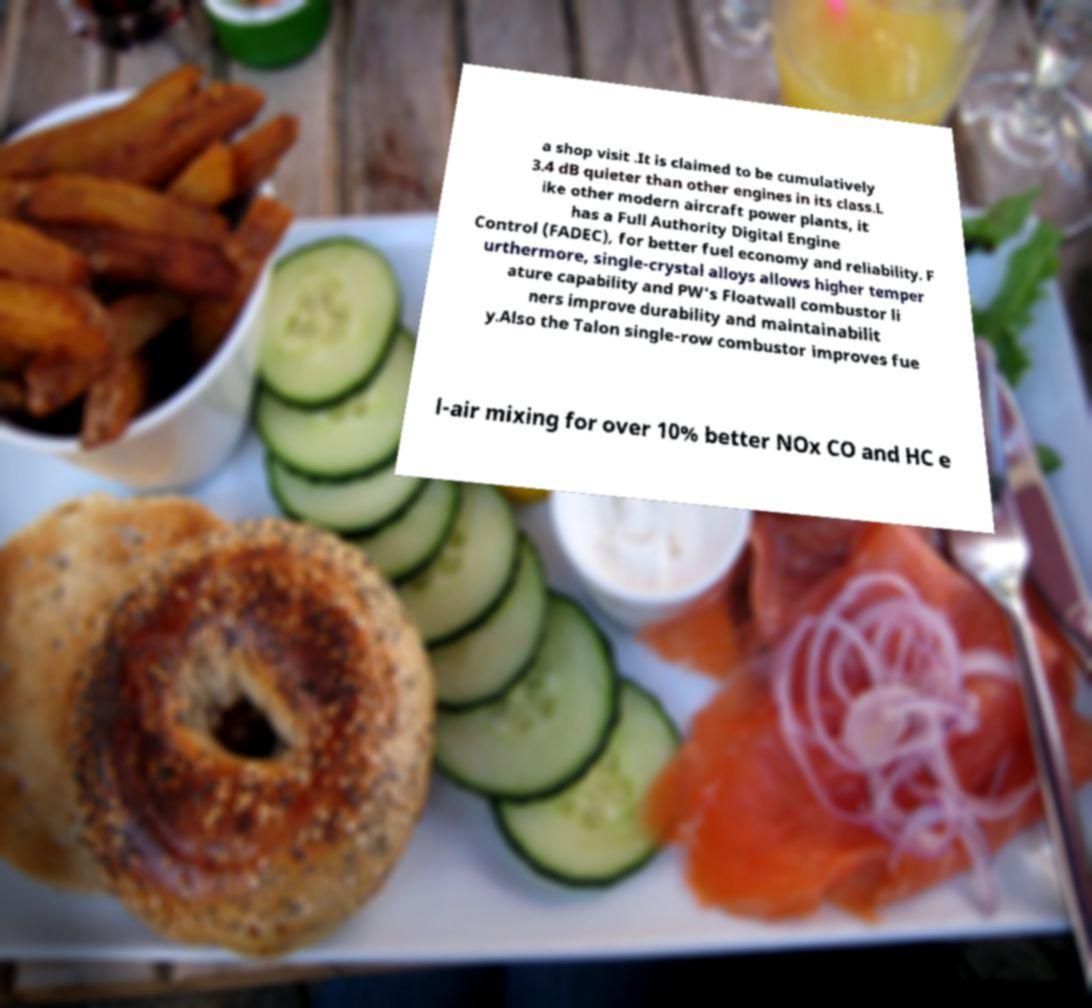Please read and relay the text visible in this image. What does it say? a shop visit .It is claimed to be cumulatively 3.4 dB quieter than other engines in its class.L ike other modern aircraft power plants, it has a Full Authority Digital Engine Control (FADEC), for better fuel economy and reliability. F urthermore, single-crystal alloys allows higher temper ature capability and PW's Floatwall combustor li ners improve durability and maintainabilit y.Also the Talon single-row combustor improves fue l-air mixing for over 10% better NOx CO and HC e 